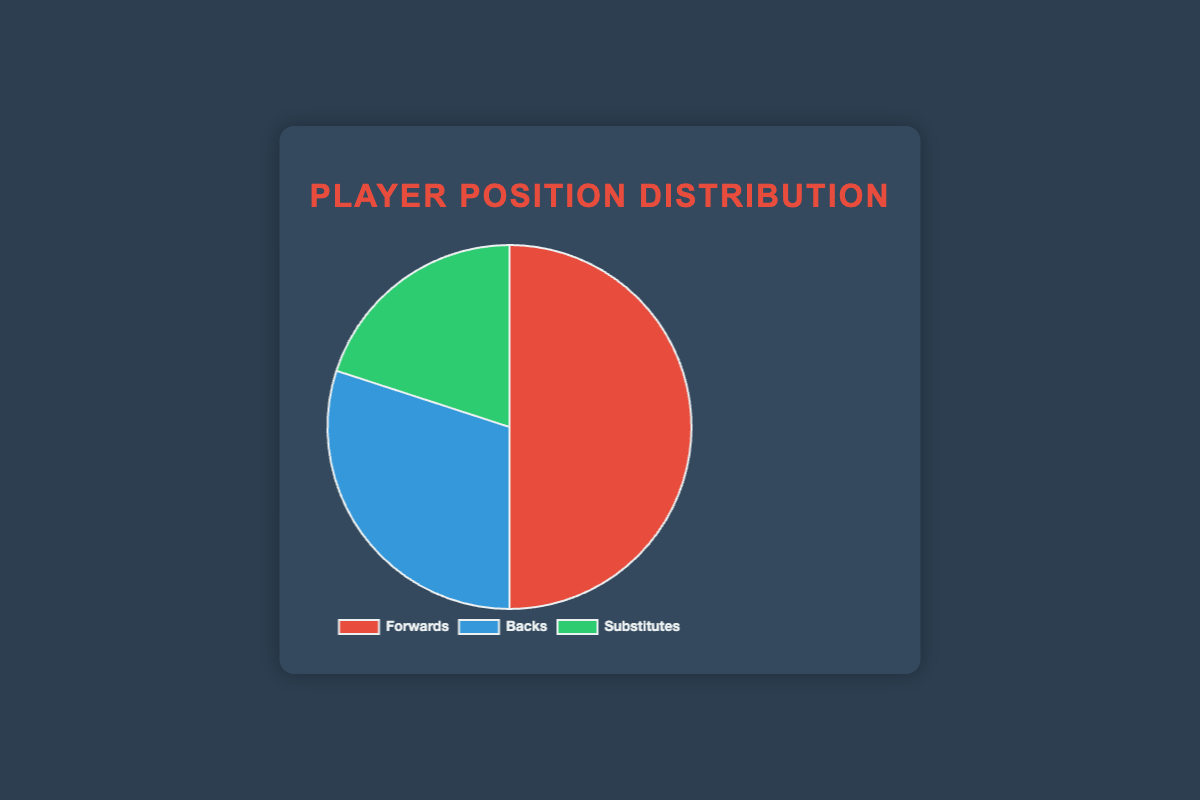What percentage of the players are Forwards? The chart indicates the distribution of player positions. The slice labeled "Forwards" represents 50% of the total players.
Answer: 50% What is the difference in the number of players between Forwards and Backs? Forwards account for 50% of the players, while Backs make up 30%. In percentage terms, the difference is 50% - 30% = 20%. Given the pie chart represents hypothetical percentages, the actual number difference would need more data.
Answer: 20% How many more percent of players are Forwards compared to Substitutes? The percentage of Forwards is 50%, while Substitutes are 20%. The difference between these percentages is 50% - 20% = 30%.
Answer: 30% Which section of the pie chart has the smallest slice, and what is its percentage? The pie chart shows three sections with Forwards at 50%, Backs at 30%, and Substitutes at 20%. The smallest slice belongs to Substitutes, which is 20%.
Answer: Substitutes, 20% What are the total combined percentages of Forwards and Backs? The Forwards make up 50% and the Backs account for 30%. Adding these together gives 50% + 30% = 80%.
Answer: 80% If you were to add 10% more players as Substitutes, what would the new percentage for Substitutes be? Current Substitutes are 20%. Adding 10% more players as Substitutes means the new percentage would be 20% + 10% = 30%.
Answer: 30% Compare and contrast the visual colors used for the Forwards and Backs sections of the pie chart. The Forwards section is represented in red, while the Backs are shown in blue. These distinct colors help differentiate the two positions clearly.
Answer: Forwards: red, Backs: blue Which player position is shown in green, and what is its significance in percentage terms? The pie chart uses green to represent Substitutes, and this segment accounts for 20% of the total players.
Answer: Substitutes, 20% What is the percentage difference between the largest and smallest sections of the pie chart? The largest section, Forwards, is 50%, and the smallest section, Substitutes, is 20%. Therefore, the percentage difference is 50% - 20% = 30%.
Answer: 30% If the team decided to have an equal percentage of Forwards and Backs, what would each of their new percentages be assuming no Substitutes? Currently, Forwards are at 50%, and Backs are at 30%. With no Substitutes (20%), the total to be distributed between Forwards and Backs would be 50% + 30% + 20% = 100%. Equally distributing this would assign 100% / 2 = 50% to both Forwards and Backs.
Answer: Each would be 50% 